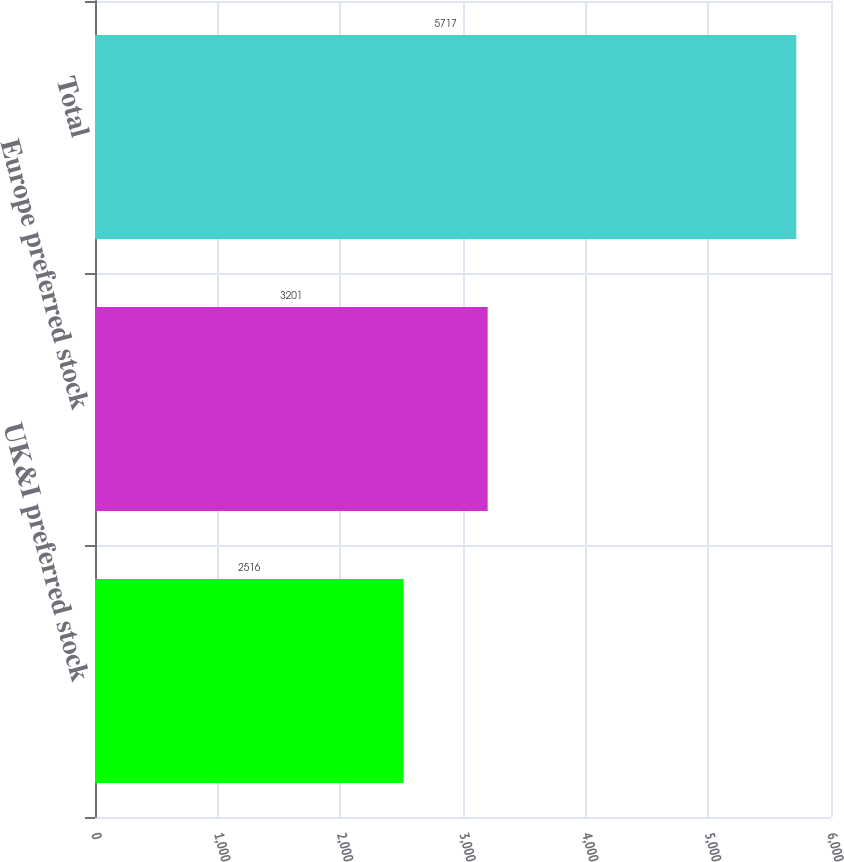<chart> <loc_0><loc_0><loc_500><loc_500><bar_chart><fcel>UK&I preferred stock<fcel>Europe preferred stock<fcel>Total<nl><fcel>2516<fcel>3201<fcel>5717<nl></chart> 